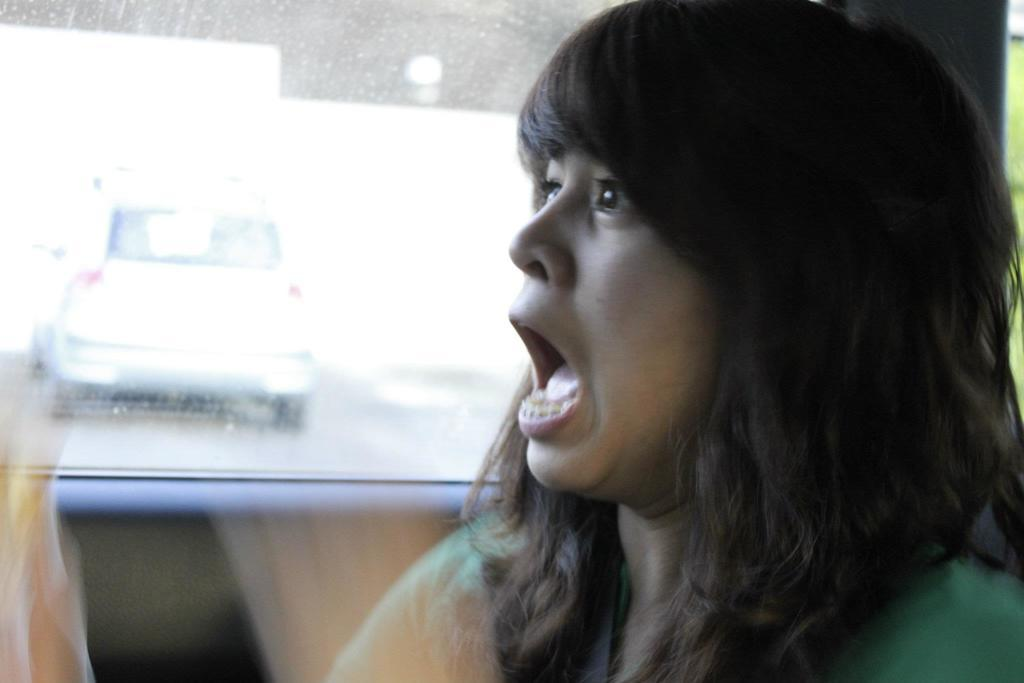What is the woman doing in the image? The woman is inside a vehicle in the image. Can you describe the vehicle the woman is in? Unfortunately, the specific details of the vehicle are not mentioned in the provided facts. What else can be seen in the image? In the background of the image, there is a car visible on the road. What color is the yak grazing in the field next to the car? There is no yak present in the image, and therefore no grazing field can be observed. 